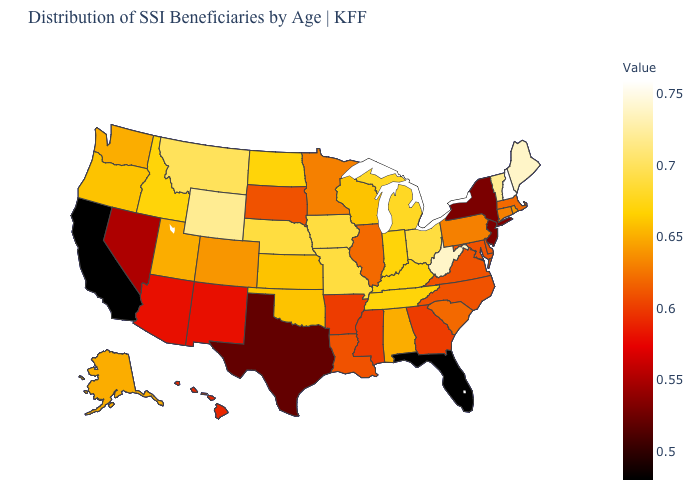Does Georgia have the highest value in the USA?
Give a very brief answer. No. Does Oregon have a higher value than New Jersey?
Write a very short answer. Yes. Does the map have missing data?
Concise answer only. No. Does North Carolina have the highest value in the USA?
Short answer required. No. 